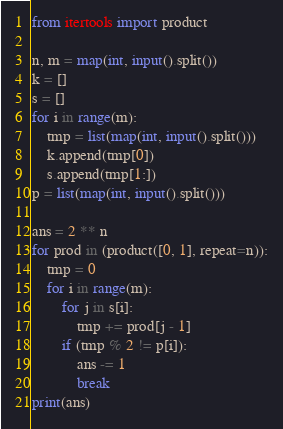<code> <loc_0><loc_0><loc_500><loc_500><_Python_>from itertools import product

n, m = map(int, input().split())
k = []
s = []
for i in range(m):
    tmp = list(map(int, input().split()))
    k.append(tmp[0])
    s.append(tmp[1:])
p = list(map(int, input().split()))

ans = 2 ** n
for prod in (product([0, 1], repeat=n)):
    tmp = 0
    for i in range(m):
        for j in s[i]:
            tmp += prod[j - 1]
        if (tmp % 2 != p[i]):
            ans -= 1
            break
print(ans)
</code> 